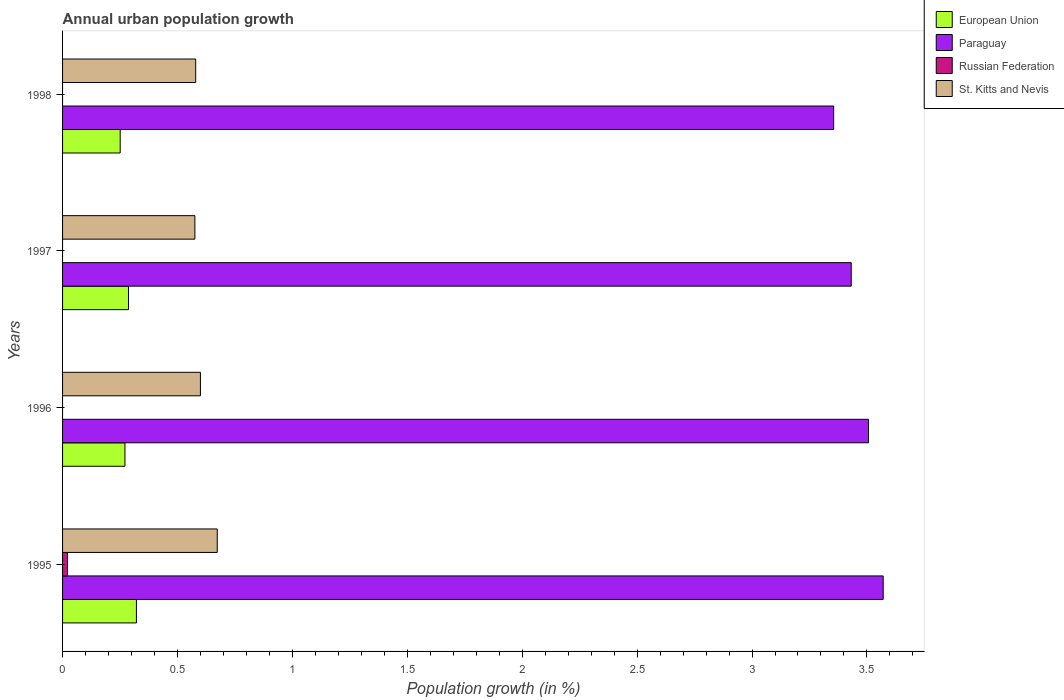How many groups of bars are there?
Your response must be concise. 4. Are the number of bars on each tick of the Y-axis equal?
Your answer should be compact. No. How many bars are there on the 3rd tick from the bottom?
Your answer should be compact. 3. What is the label of the 3rd group of bars from the top?
Offer a very short reply. 1996. In how many cases, is the number of bars for a given year not equal to the number of legend labels?
Offer a terse response. 3. What is the percentage of urban population growth in Russian Federation in 1998?
Ensure brevity in your answer.  0. Across all years, what is the maximum percentage of urban population growth in Paraguay?
Keep it short and to the point. 3.57. Across all years, what is the minimum percentage of urban population growth in St. Kitts and Nevis?
Provide a succinct answer. 0.58. In which year was the percentage of urban population growth in European Union maximum?
Make the answer very short. 1995. What is the total percentage of urban population growth in European Union in the graph?
Ensure brevity in your answer.  1.13. What is the difference between the percentage of urban population growth in Paraguay in 1995 and that in 1998?
Provide a succinct answer. 0.22. What is the difference between the percentage of urban population growth in St. Kitts and Nevis in 1996 and the percentage of urban population growth in Russian Federation in 1995?
Offer a terse response. 0.58. What is the average percentage of urban population growth in Paraguay per year?
Provide a succinct answer. 3.47. In the year 1995, what is the difference between the percentage of urban population growth in Russian Federation and percentage of urban population growth in Paraguay?
Give a very brief answer. -3.55. What is the ratio of the percentage of urban population growth in St. Kitts and Nevis in 1995 to that in 1998?
Provide a succinct answer. 1.16. What is the difference between the highest and the second highest percentage of urban population growth in St. Kitts and Nevis?
Offer a very short reply. 0.07. What is the difference between the highest and the lowest percentage of urban population growth in St. Kitts and Nevis?
Offer a terse response. 0.1. In how many years, is the percentage of urban population growth in Paraguay greater than the average percentage of urban population growth in Paraguay taken over all years?
Offer a very short reply. 2. Is it the case that in every year, the sum of the percentage of urban population growth in St. Kitts and Nevis and percentage of urban population growth in European Union is greater than the sum of percentage of urban population growth in Paraguay and percentage of urban population growth in Russian Federation?
Keep it short and to the point. No. How many bars are there?
Ensure brevity in your answer.  13. Are all the bars in the graph horizontal?
Offer a very short reply. Yes. What is the difference between two consecutive major ticks on the X-axis?
Provide a succinct answer. 0.5. Are the values on the major ticks of X-axis written in scientific E-notation?
Ensure brevity in your answer.  No. Does the graph contain any zero values?
Your answer should be compact. Yes. Does the graph contain grids?
Keep it short and to the point. No. Where does the legend appear in the graph?
Your response must be concise. Top right. What is the title of the graph?
Offer a terse response. Annual urban population growth. Does "Norway" appear as one of the legend labels in the graph?
Provide a short and direct response. No. What is the label or title of the X-axis?
Your answer should be compact. Population growth (in %). What is the Population growth (in %) of European Union in 1995?
Give a very brief answer. 0.32. What is the Population growth (in %) of Paraguay in 1995?
Give a very brief answer. 3.57. What is the Population growth (in %) in Russian Federation in 1995?
Provide a succinct answer. 0.02. What is the Population growth (in %) of St. Kitts and Nevis in 1995?
Provide a short and direct response. 0.67. What is the Population growth (in %) of European Union in 1996?
Your response must be concise. 0.27. What is the Population growth (in %) in Paraguay in 1996?
Ensure brevity in your answer.  3.51. What is the Population growth (in %) in St. Kitts and Nevis in 1996?
Your response must be concise. 0.6. What is the Population growth (in %) in European Union in 1997?
Your answer should be very brief. 0.29. What is the Population growth (in %) in Paraguay in 1997?
Your answer should be very brief. 3.43. What is the Population growth (in %) in St. Kitts and Nevis in 1997?
Offer a very short reply. 0.58. What is the Population growth (in %) in European Union in 1998?
Your response must be concise. 0.25. What is the Population growth (in %) of Paraguay in 1998?
Your answer should be compact. 3.36. What is the Population growth (in %) of Russian Federation in 1998?
Your answer should be very brief. 0. What is the Population growth (in %) in St. Kitts and Nevis in 1998?
Your answer should be compact. 0.58. Across all years, what is the maximum Population growth (in %) in European Union?
Your answer should be very brief. 0.32. Across all years, what is the maximum Population growth (in %) of Paraguay?
Offer a terse response. 3.57. Across all years, what is the maximum Population growth (in %) in Russian Federation?
Keep it short and to the point. 0.02. Across all years, what is the maximum Population growth (in %) of St. Kitts and Nevis?
Your answer should be very brief. 0.67. Across all years, what is the minimum Population growth (in %) in European Union?
Give a very brief answer. 0.25. Across all years, what is the minimum Population growth (in %) in Paraguay?
Your response must be concise. 3.36. Across all years, what is the minimum Population growth (in %) in Russian Federation?
Ensure brevity in your answer.  0. Across all years, what is the minimum Population growth (in %) of St. Kitts and Nevis?
Your answer should be compact. 0.58. What is the total Population growth (in %) of European Union in the graph?
Provide a succinct answer. 1.13. What is the total Population growth (in %) of Paraguay in the graph?
Provide a succinct answer. 13.86. What is the total Population growth (in %) in Russian Federation in the graph?
Your response must be concise. 0.02. What is the total Population growth (in %) of St. Kitts and Nevis in the graph?
Provide a succinct answer. 2.43. What is the difference between the Population growth (in %) of European Union in 1995 and that in 1996?
Give a very brief answer. 0.05. What is the difference between the Population growth (in %) of Paraguay in 1995 and that in 1996?
Your response must be concise. 0.06. What is the difference between the Population growth (in %) in St. Kitts and Nevis in 1995 and that in 1996?
Offer a very short reply. 0.07. What is the difference between the Population growth (in %) of European Union in 1995 and that in 1997?
Your response must be concise. 0.03. What is the difference between the Population growth (in %) in Paraguay in 1995 and that in 1997?
Offer a very short reply. 0.14. What is the difference between the Population growth (in %) of St. Kitts and Nevis in 1995 and that in 1997?
Make the answer very short. 0.1. What is the difference between the Population growth (in %) of European Union in 1995 and that in 1998?
Give a very brief answer. 0.07. What is the difference between the Population growth (in %) of Paraguay in 1995 and that in 1998?
Provide a succinct answer. 0.22. What is the difference between the Population growth (in %) of St. Kitts and Nevis in 1995 and that in 1998?
Provide a short and direct response. 0.09. What is the difference between the Population growth (in %) of European Union in 1996 and that in 1997?
Make the answer very short. -0.02. What is the difference between the Population growth (in %) in Paraguay in 1996 and that in 1997?
Provide a succinct answer. 0.08. What is the difference between the Population growth (in %) in St. Kitts and Nevis in 1996 and that in 1997?
Ensure brevity in your answer.  0.02. What is the difference between the Population growth (in %) of European Union in 1996 and that in 1998?
Your response must be concise. 0.02. What is the difference between the Population growth (in %) of Paraguay in 1996 and that in 1998?
Ensure brevity in your answer.  0.15. What is the difference between the Population growth (in %) in St. Kitts and Nevis in 1996 and that in 1998?
Provide a short and direct response. 0.02. What is the difference between the Population growth (in %) in European Union in 1997 and that in 1998?
Offer a very short reply. 0.04. What is the difference between the Population growth (in %) in Paraguay in 1997 and that in 1998?
Your answer should be compact. 0.08. What is the difference between the Population growth (in %) of St. Kitts and Nevis in 1997 and that in 1998?
Your answer should be compact. -0. What is the difference between the Population growth (in %) in European Union in 1995 and the Population growth (in %) in Paraguay in 1996?
Make the answer very short. -3.19. What is the difference between the Population growth (in %) in European Union in 1995 and the Population growth (in %) in St. Kitts and Nevis in 1996?
Give a very brief answer. -0.28. What is the difference between the Population growth (in %) of Paraguay in 1995 and the Population growth (in %) of St. Kitts and Nevis in 1996?
Offer a very short reply. 2.97. What is the difference between the Population growth (in %) of Russian Federation in 1995 and the Population growth (in %) of St. Kitts and Nevis in 1996?
Provide a succinct answer. -0.58. What is the difference between the Population growth (in %) in European Union in 1995 and the Population growth (in %) in Paraguay in 1997?
Make the answer very short. -3.11. What is the difference between the Population growth (in %) in European Union in 1995 and the Population growth (in %) in St. Kitts and Nevis in 1997?
Your answer should be compact. -0.25. What is the difference between the Population growth (in %) of Paraguay in 1995 and the Population growth (in %) of St. Kitts and Nevis in 1997?
Your answer should be very brief. 3. What is the difference between the Population growth (in %) in Russian Federation in 1995 and the Population growth (in %) in St. Kitts and Nevis in 1997?
Your answer should be very brief. -0.55. What is the difference between the Population growth (in %) in European Union in 1995 and the Population growth (in %) in Paraguay in 1998?
Give a very brief answer. -3.03. What is the difference between the Population growth (in %) of European Union in 1995 and the Population growth (in %) of St. Kitts and Nevis in 1998?
Your answer should be very brief. -0.26. What is the difference between the Population growth (in %) of Paraguay in 1995 and the Population growth (in %) of St. Kitts and Nevis in 1998?
Keep it short and to the point. 2.99. What is the difference between the Population growth (in %) in Russian Federation in 1995 and the Population growth (in %) in St. Kitts and Nevis in 1998?
Keep it short and to the point. -0.56. What is the difference between the Population growth (in %) in European Union in 1996 and the Population growth (in %) in Paraguay in 1997?
Make the answer very short. -3.16. What is the difference between the Population growth (in %) of European Union in 1996 and the Population growth (in %) of St. Kitts and Nevis in 1997?
Provide a succinct answer. -0.3. What is the difference between the Population growth (in %) in Paraguay in 1996 and the Population growth (in %) in St. Kitts and Nevis in 1997?
Your answer should be very brief. 2.93. What is the difference between the Population growth (in %) of European Union in 1996 and the Population growth (in %) of Paraguay in 1998?
Ensure brevity in your answer.  -3.08. What is the difference between the Population growth (in %) in European Union in 1996 and the Population growth (in %) in St. Kitts and Nevis in 1998?
Give a very brief answer. -0.31. What is the difference between the Population growth (in %) in Paraguay in 1996 and the Population growth (in %) in St. Kitts and Nevis in 1998?
Your answer should be compact. 2.93. What is the difference between the Population growth (in %) of European Union in 1997 and the Population growth (in %) of Paraguay in 1998?
Provide a short and direct response. -3.07. What is the difference between the Population growth (in %) in European Union in 1997 and the Population growth (in %) in St. Kitts and Nevis in 1998?
Provide a short and direct response. -0.29. What is the difference between the Population growth (in %) in Paraguay in 1997 and the Population growth (in %) in St. Kitts and Nevis in 1998?
Provide a short and direct response. 2.85. What is the average Population growth (in %) in European Union per year?
Give a very brief answer. 0.28. What is the average Population growth (in %) of Paraguay per year?
Ensure brevity in your answer.  3.47. What is the average Population growth (in %) of Russian Federation per year?
Ensure brevity in your answer.  0.01. What is the average Population growth (in %) in St. Kitts and Nevis per year?
Make the answer very short. 0.61. In the year 1995, what is the difference between the Population growth (in %) in European Union and Population growth (in %) in Paraguay?
Keep it short and to the point. -3.25. In the year 1995, what is the difference between the Population growth (in %) of European Union and Population growth (in %) of St. Kitts and Nevis?
Offer a very short reply. -0.35. In the year 1995, what is the difference between the Population growth (in %) in Paraguay and Population growth (in %) in Russian Federation?
Your response must be concise. 3.55. In the year 1995, what is the difference between the Population growth (in %) in Paraguay and Population growth (in %) in St. Kitts and Nevis?
Your response must be concise. 2.9. In the year 1995, what is the difference between the Population growth (in %) in Russian Federation and Population growth (in %) in St. Kitts and Nevis?
Give a very brief answer. -0.65. In the year 1996, what is the difference between the Population growth (in %) of European Union and Population growth (in %) of Paraguay?
Provide a short and direct response. -3.24. In the year 1996, what is the difference between the Population growth (in %) of European Union and Population growth (in %) of St. Kitts and Nevis?
Ensure brevity in your answer.  -0.33. In the year 1996, what is the difference between the Population growth (in %) of Paraguay and Population growth (in %) of St. Kitts and Nevis?
Your answer should be very brief. 2.91. In the year 1997, what is the difference between the Population growth (in %) in European Union and Population growth (in %) in Paraguay?
Give a very brief answer. -3.14. In the year 1997, what is the difference between the Population growth (in %) of European Union and Population growth (in %) of St. Kitts and Nevis?
Provide a succinct answer. -0.29. In the year 1997, what is the difference between the Population growth (in %) of Paraguay and Population growth (in %) of St. Kitts and Nevis?
Offer a very short reply. 2.86. In the year 1998, what is the difference between the Population growth (in %) of European Union and Population growth (in %) of Paraguay?
Offer a terse response. -3.1. In the year 1998, what is the difference between the Population growth (in %) of European Union and Population growth (in %) of St. Kitts and Nevis?
Make the answer very short. -0.33. In the year 1998, what is the difference between the Population growth (in %) of Paraguay and Population growth (in %) of St. Kitts and Nevis?
Ensure brevity in your answer.  2.78. What is the ratio of the Population growth (in %) of European Union in 1995 to that in 1996?
Your response must be concise. 1.18. What is the ratio of the Population growth (in %) in Paraguay in 1995 to that in 1996?
Offer a terse response. 1.02. What is the ratio of the Population growth (in %) in St. Kitts and Nevis in 1995 to that in 1996?
Give a very brief answer. 1.12. What is the ratio of the Population growth (in %) in European Union in 1995 to that in 1997?
Offer a terse response. 1.12. What is the ratio of the Population growth (in %) of Paraguay in 1995 to that in 1997?
Offer a terse response. 1.04. What is the ratio of the Population growth (in %) in St. Kitts and Nevis in 1995 to that in 1997?
Offer a terse response. 1.17. What is the ratio of the Population growth (in %) in European Union in 1995 to that in 1998?
Offer a very short reply. 1.28. What is the ratio of the Population growth (in %) in Paraguay in 1995 to that in 1998?
Ensure brevity in your answer.  1.06. What is the ratio of the Population growth (in %) in St. Kitts and Nevis in 1995 to that in 1998?
Provide a succinct answer. 1.16. What is the ratio of the Population growth (in %) of European Union in 1996 to that in 1997?
Your answer should be compact. 0.95. What is the ratio of the Population growth (in %) of Paraguay in 1996 to that in 1997?
Give a very brief answer. 1.02. What is the ratio of the Population growth (in %) of St. Kitts and Nevis in 1996 to that in 1997?
Your response must be concise. 1.04. What is the ratio of the Population growth (in %) of European Union in 1996 to that in 1998?
Ensure brevity in your answer.  1.08. What is the ratio of the Population growth (in %) of Paraguay in 1996 to that in 1998?
Your answer should be compact. 1.05. What is the ratio of the Population growth (in %) of St. Kitts and Nevis in 1996 to that in 1998?
Provide a succinct answer. 1.04. What is the ratio of the Population growth (in %) in European Union in 1997 to that in 1998?
Your answer should be very brief. 1.14. What is the ratio of the Population growth (in %) in Paraguay in 1997 to that in 1998?
Your answer should be compact. 1.02. What is the ratio of the Population growth (in %) in St. Kitts and Nevis in 1997 to that in 1998?
Offer a very short reply. 0.99. What is the difference between the highest and the second highest Population growth (in %) of European Union?
Your answer should be very brief. 0.03. What is the difference between the highest and the second highest Population growth (in %) in Paraguay?
Provide a short and direct response. 0.06. What is the difference between the highest and the second highest Population growth (in %) of St. Kitts and Nevis?
Keep it short and to the point. 0.07. What is the difference between the highest and the lowest Population growth (in %) of European Union?
Make the answer very short. 0.07. What is the difference between the highest and the lowest Population growth (in %) in Paraguay?
Give a very brief answer. 0.22. What is the difference between the highest and the lowest Population growth (in %) in Russian Federation?
Ensure brevity in your answer.  0.02. What is the difference between the highest and the lowest Population growth (in %) of St. Kitts and Nevis?
Offer a terse response. 0.1. 